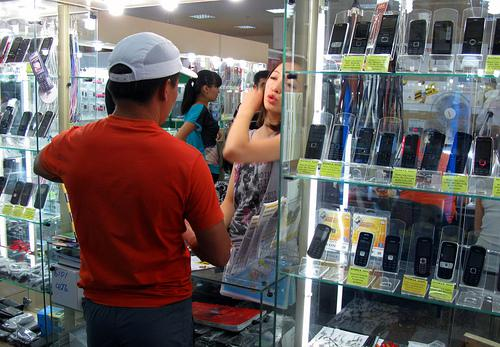Question: what is the woman selling?
Choices:
A. Computers.
B. Televisions.
C. Video Games.
D. Cell phones.
Answer with the letter. Answer: D Question: what is on the man in the foreground's head?
Choices:
A. Hat.
B. Sun visor.
C. Bandanna.
D. Scarf.
Answer with the letter. Answer: A Question: where is this picture taken?
Choices:
A. Home.
B. School.
C. Store.
D. Office.
Answer with the letter. Answer: C Question: what color is the man in the foreground's shirt?
Choices:
A. Blue.
B. Red.
C. Green.
D. Yellow.
Answer with the letter. Answer: B Question: who is wearing a blue shirt?
Choices:
A. The man in the background.
B. The woman in the background.
C. The man in front.
D. The woman in front.
Answer with the letter. Answer: B Question: where are the cell phones?
Choices:
A. On the table.
B. Cases.
C. On the desk.
D. In their purses.
Answer with the letter. Answer: B Question: why are the phones in clear packaging?
Choices:
A. So they stack easier.
B. So they can be seen.
C. So they don't break if they fall.
D. So accessories can be put in as well.
Answer with the letter. Answer: B 